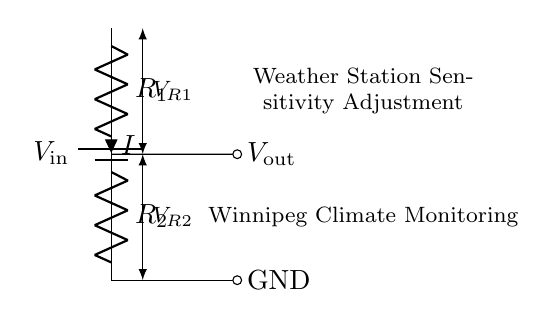What is the type of circuit shown? The circuit is a voltage divider circuit, which is designed to divide the input voltage into smaller output voltages based on the resistor values.
Answer: Voltage divider What components are present in the circuit? The circuit contains a battery, two resistors, and output connections for voltage measurement. The battery provides the input voltage, while the resistors are used to create the voltage division.
Answer: Battery and two resistors What does Vout represent in this circuit? Vout represents the output voltage across the second resistor (R2), which is a part of the voltage divider equation that determines how much voltage is supplied to the weather station's sensors.
Answer: Output voltage What is the relationship of current in this circuit? The current (I) flowing through the circuit is the same through both resistors, as they are arranged in series. This series configuration means that the same amount of current flows through R1 and R2.
Answer: Same current How can you calculate Vout in this circuit? Vout can be calculated using the formula Vout = Vin * (R2 / (R1 + R2)), where Vin is the input voltage, and R1 and R2 are the resistor values. This ratio shows how the total voltage is divided between the resistors based on their resistance values.
Answer: Vout = Vin * (R2 / (R1 + R2)) What adjustment does this circuit allow for the weather station? This circuit allows for adjusting the sensitivity of the weather station by changing the values of resistors R1 and R2, which in turn modifies the output voltage Vout. This ensures that the sensors receive the appropriate voltage for accurate readings.
Answer: Sensitivity adjustment What role do R1 and R2 play in the voltage divider? R1 and R2 determine how much of the input voltage is dropped across each resistor. Their ratio affects the output voltage available to the weather station, allowing it to respond effectively to varying environmental conditions.
Answer: Voltage division 